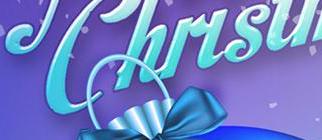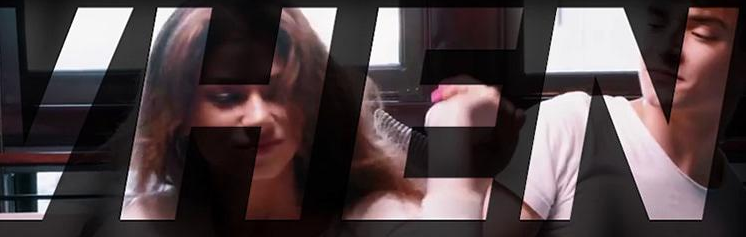What words are shown in these images in order, separated by a semicolon? Chirsu; VHEN 